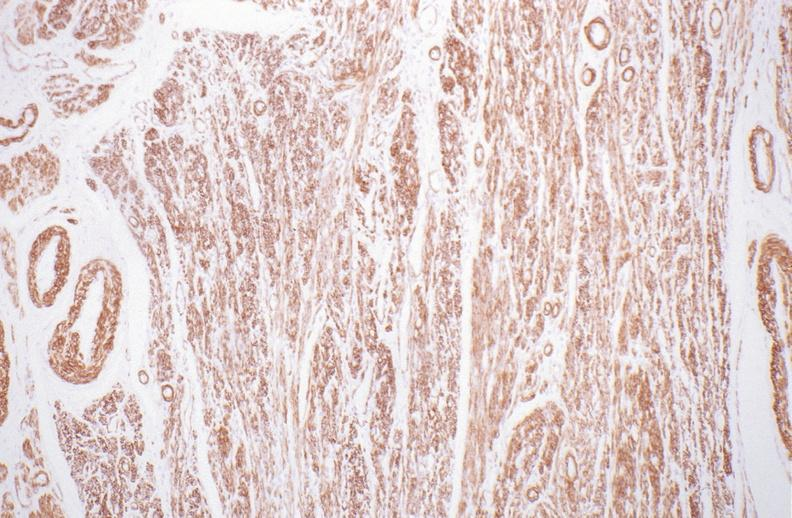do aldehyde fuscin stain?
Answer the question using a single word or phrase. No 